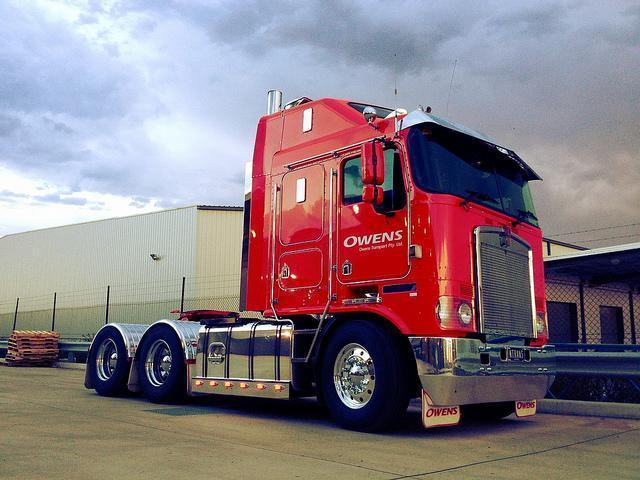How many people on the court are in orange?
Give a very brief answer. 0. 